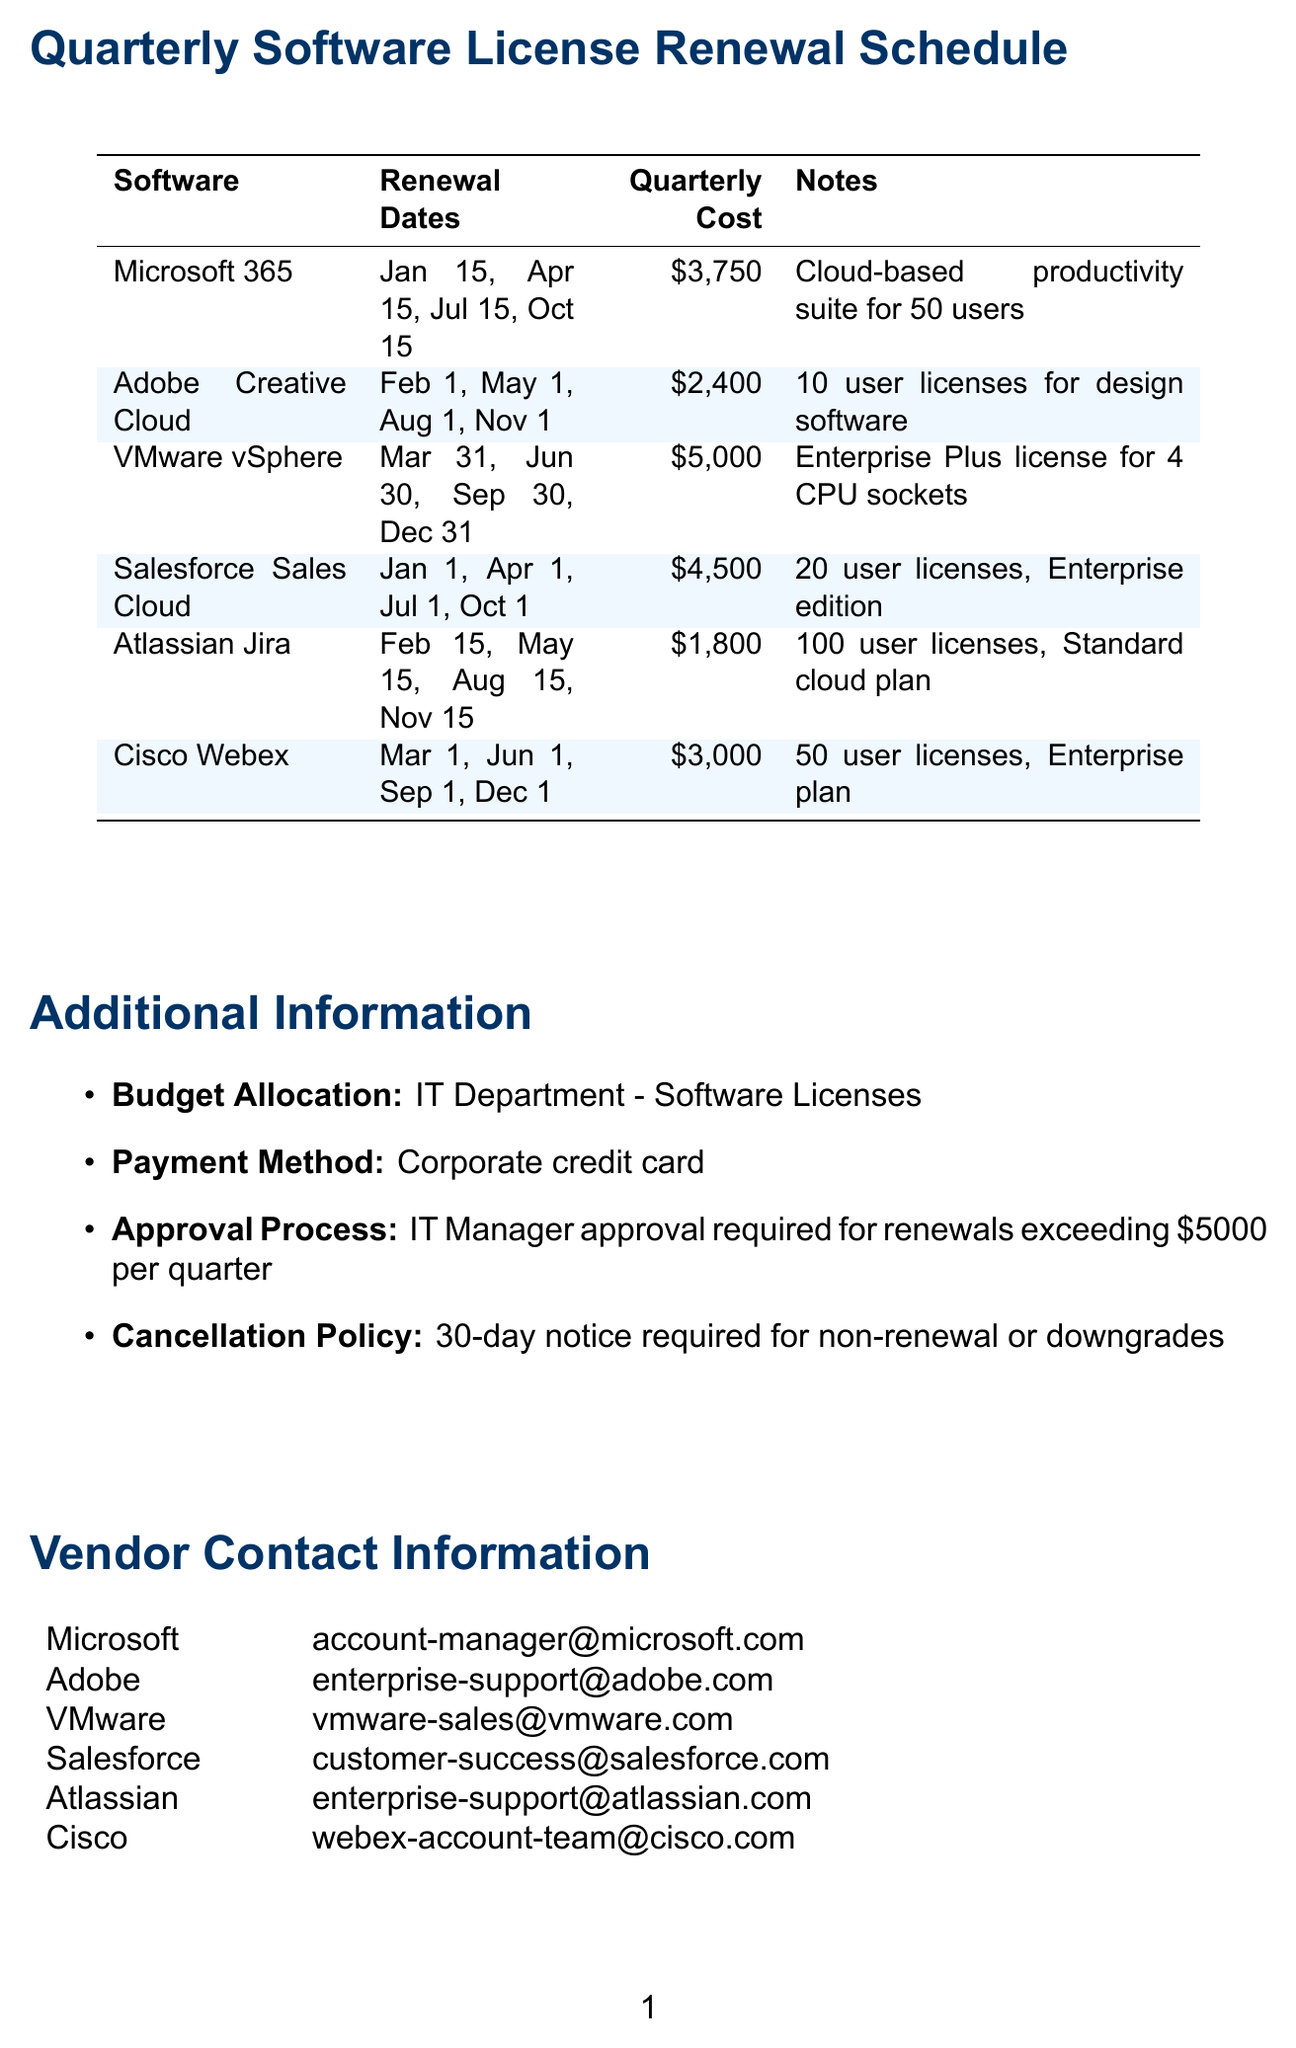What is the renewal date for Microsoft 365 in April? The renewal date for Microsoft 365 in April is explicitly listed in the schedule.
Answer: April 15 How many user licenses are included with Adobe Creative Cloud? The document specifies that Adobe Creative Cloud includes 10 user licenses.
Answer: 10 user licenses What is the quarterly cost of VMware vSphere? The quarterly cost for VMware vSphere is stated in the cost breakdown in the table.
Answer: $5,000 What is the total annual cost for Salesforce Sales Cloud? The total annual cost for Salesforce Sales Cloud is provided as part of the annual cost listings.
Answer: $18,000 What is the cancellation policy for software licenses? The cancellation policy is outlined in the additional information section of the document.
Answer: 30-day notice required for non-renewal or downgrades Which software requires IT Manager approval for renewals exceeding a certain amount? The document mentions that renewals exceeding a set amount require IT Manager approval, indicating a specific approval process.
Answer: $5,000 What type of software is Cisco Webex? The document categorizes Cisco Webex under a specific type, indicating its nature.
Answer: Video conferencing and collaboration When is the next renewal date for Atlassian Jira? The document indicates the renewal dates, specifying the first one that will come next.
Answer: February 15 How many quarterly breakdowns are listed for each software? The structure of the document suggests a fixed number of breakdowns for each software's cost.
Answer: 4 quarterly breakdowns 